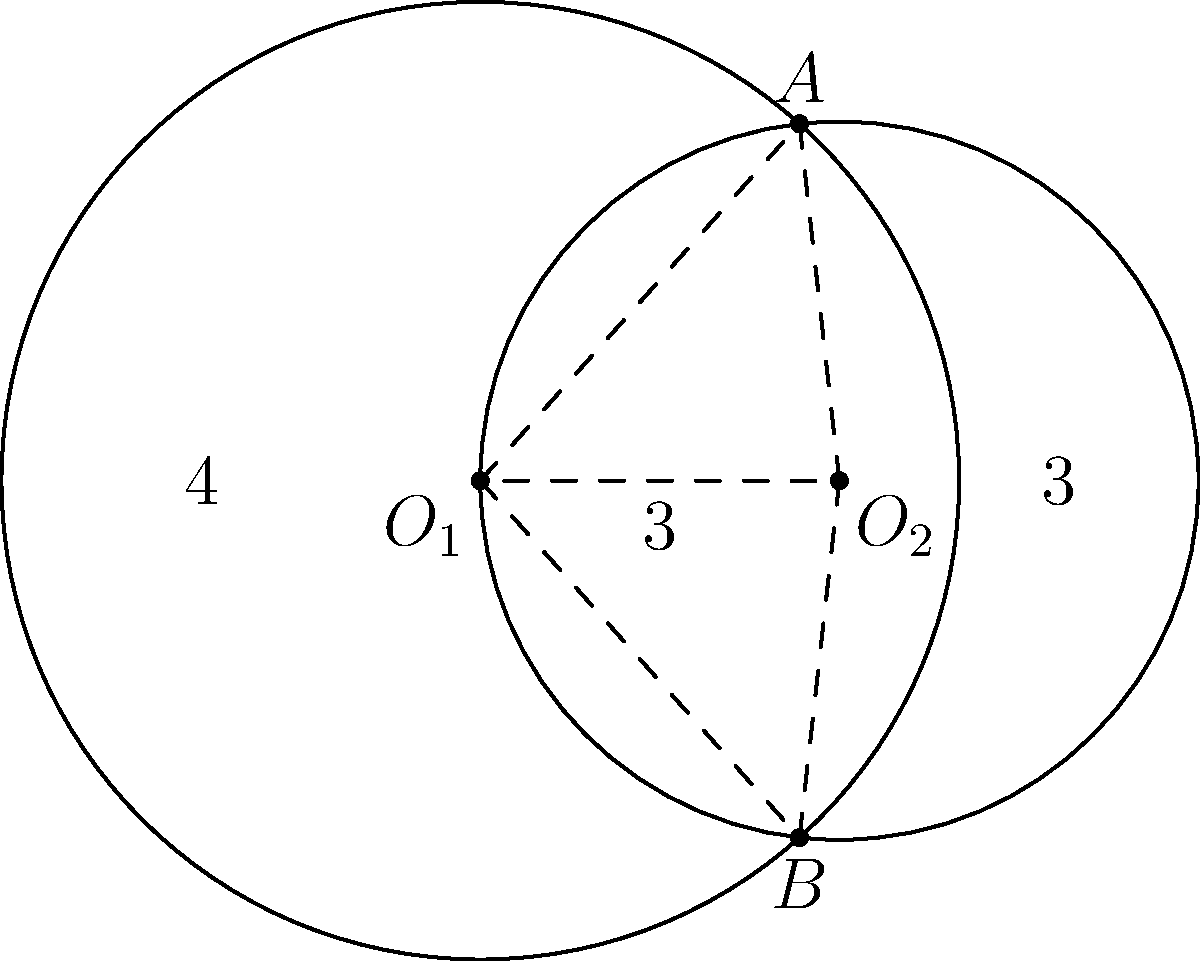In the context of historical artifact restoration, you encounter two overlapping circular stains on an ancient manuscript. The stains are represented by two intersecting circles with centers $O_1$ and $O_2$. Circle $O_1$ has a radius of 4 units, circle $O_2$ has a radius of 3 units, and the distance between their centers is 3 units. Calculate the area of the region where the stains overlap, which is crucial for determining the extent of the restoration needed. Round your answer to two decimal places. To find the area of the overlapping region, we'll follow these steps:

1) First, we need to find the angle $\theta$ at the center of each circle that corresponds to the overlapping region.

2) For circle $O_1$:
   $\cos(\frac{\theta_1}{2}) = \frac{3}{4}$
   $\theta_1 = 2 \arccos(\frac{3}{4}) \approx 2.0944$ radians

3) For circle $O_2$:
   $\cos(\frac{\theta_2}{2}) = \frac{3}{3} = 1$
   $\theta_2 = 2 \arccos(1) = 0$ radians

4) The area of a circular sector is given by $\frac{1}{2}r^2\theta$, where $r$ is the radius and $\theta$ is the central angle in radians.

5) Area of sector in circle $O_1$: $A_1 = \frac{1}{2} \cdot 4^2 \cdot 2.0944 \approx 16.7552$

6) Area of sector in circle $O_2$: $A_2 = \frac{1}{2} \cdot 3^2 \cdot 0 = 0$

7) Area of triangle $O_1AO_2$: $A_t = \frac{1}{2} \cdot 3 \cdot 4 \cdot \sin(\arccos(\frac{3}{4})) \approx 2.5981$

8) The overlapping area is:
   $A_{overlap} = A_1 + A_2 - 2A_t \approx 16.7552 + 0 - 2(2.5981) = 11.5590$

9) Rounding to two decimal places: 11.56
Answer: 11.56 square units 